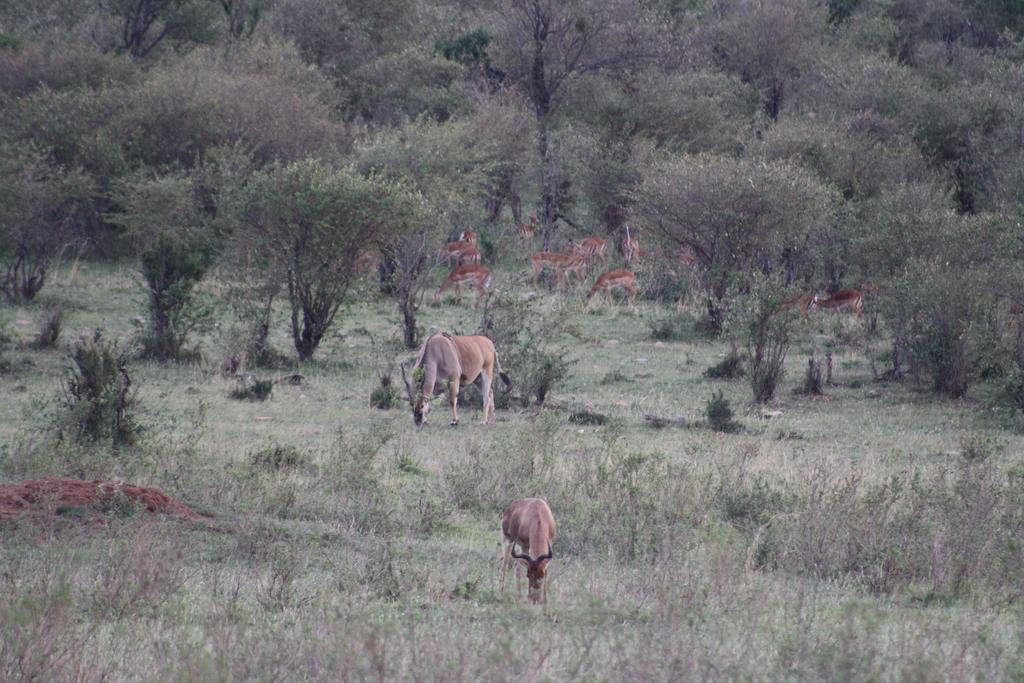What type of terrain is visible in the image? There is an open grass ground in the image. What animals can be seen on the grass ground? There are deer on the grass ground. What can be seen in the distance in the image? There are trees in the background of the image. What is the price of the advertisement displayed on the grass ground? There is no advertisement present in the image; it features an open grass ground with deer. 